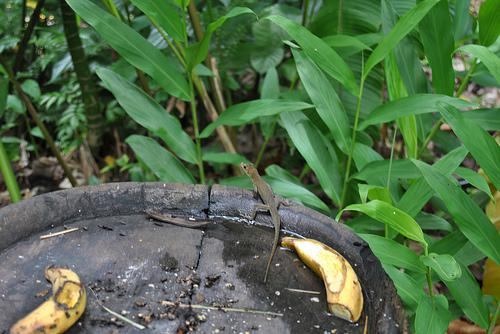Question: what is the fruit called?
Choices:
A. Banana.
B. Orange.
C. Pear.
D. Apple.
Answer with the letter. Answer: A Question: where was the picture taken?
Choices:
A. Ocean.
B. Mountain trail.
C. Woods.
D. Busy street.
Answer with the letter. Answer: C Question: how did the banana get a hole?
Choices:
A. Hungry child.
B. It rotted.
C. Sharp knife.
D. Stepped on.
Answer with the letter. Answer: B 